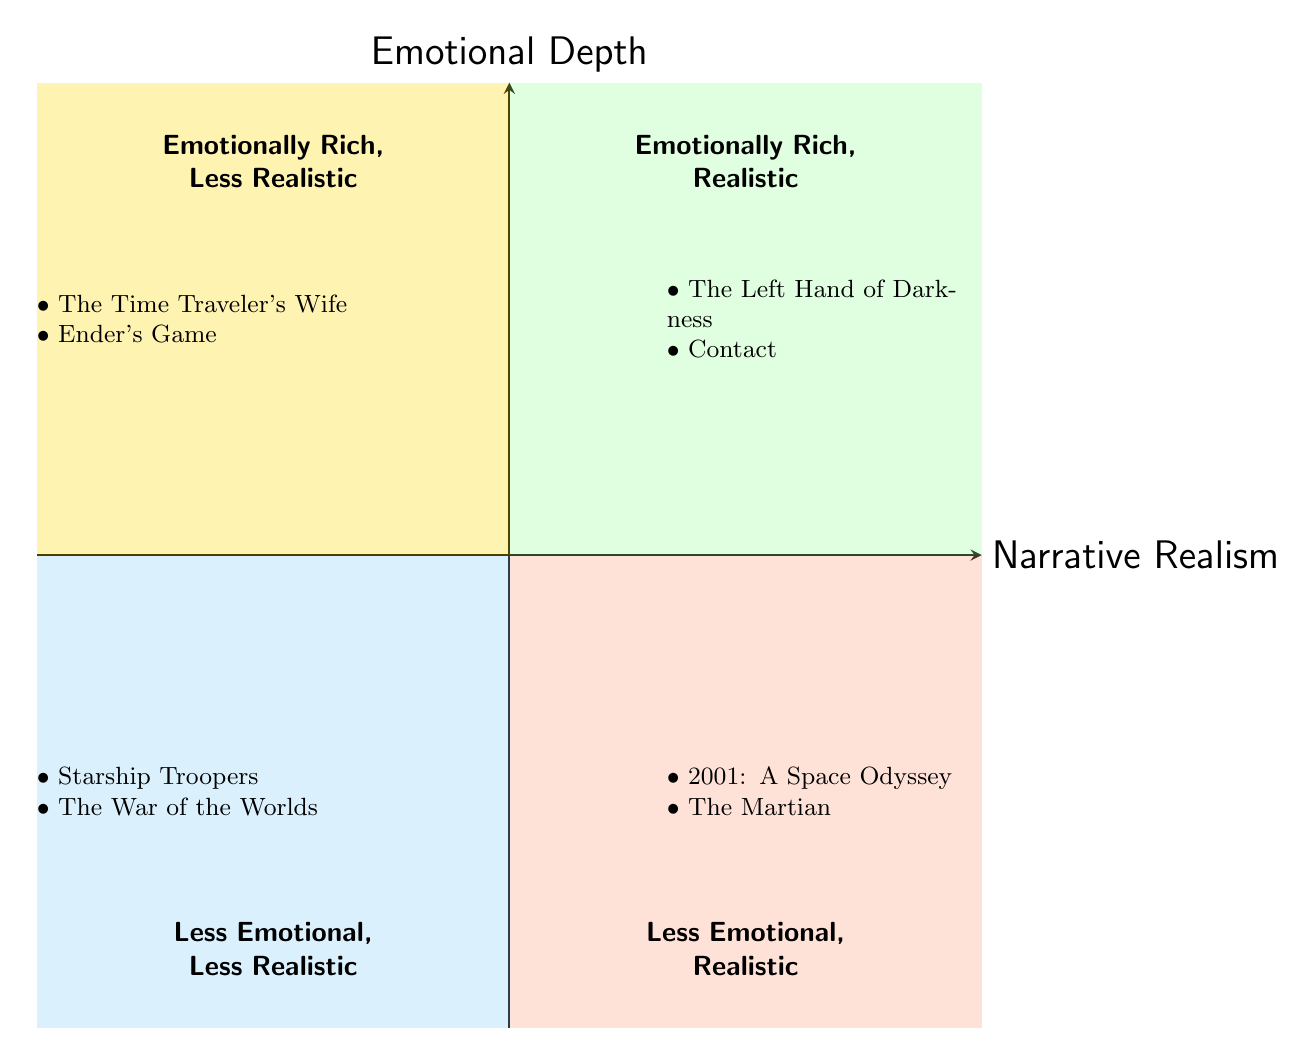What are the examples in the top left quadrant? The top left quadrant is titled "Emotionally Rich, Less Realistic" and contains two examples listed: "The Time Traveler's Wife" and "Ender's Game."
Answer: The Time Traveler's Wife, Ender's Game Which quadrant has "The Martian"? "The Martian" is located in the bottom right quadrant, which is labeled "Less Emotional, Realistic."
Answer: Less Emotional, Realistic How many examples are in the bottom left quadrant? The bottom left quadrant is labeled "Less Emotional, Less Realistic" and features two examples: "Starship Troopers" and "The War of the Worlds."
Answer: 2 What distinguishes the quadrants regarding emotional depth? The quadrants are separated vertically by emotional depth, with the top quadrants being "Emotionally Rich" and the bottom quadrants being "Less Emotional."
Answer: Emotionally Rich, Less Emotional Which quadrant contains the exploration of gender relationships? The quadrant that includes the exploration of gender and relationships on alien planets is the top right quadrant, titled "Emotionally Rich, Realistic."
Answer: Emotionally Rich, Realistic In which quadrant can we find works with minimal emotional development? The bottom left quadrant includes works with minimal emotional development, specifically labeled "Less Emotional, Less Realistic."
Answer: Less Emotional, Less Realistic How are military-themed relationships classified in this diagram? Military-themed relationships are classified in the bottom left quadrant labeled "Less Emotional, Less Realistic," which indicates surface-level relationships.
Answer: Less Emotional, Less Realistic What is the focus of the examples in the top right quadrant? The top right quadrant focuses on emotionally rich narratives that maintain a sense of realism, highlighting scientific or social authenticity in interstellar love.
Answer: Exploration of relationships with authenticity 